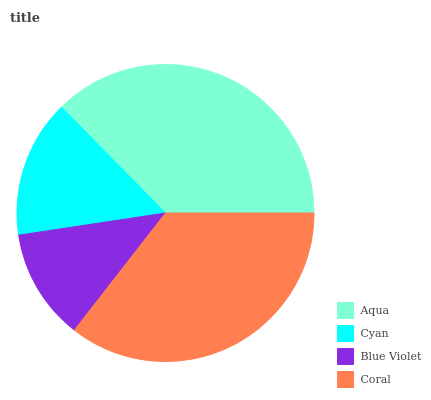Is Blue Violet the minimum?
Answer yes or no. Yes. Is Aqua the maximum?
Answer yes or no. Yes. Is Cyan the minimum?
Answer yes or no. No. Is Cyan the maximum?
Answer yes or no. No. Is Aqua greater than Cyan?
Answer yes or no. Yes. Is Cyan less than Aqua?
Answer yes or no. Yes. Is Cyan greater than Aqua?
Answer yes or no. No. Is Aqua less than Cyan?
Answer yes or no. No. Is Coral the high median?
Answer yes or no. Yes. Is Cyan the low median?
Answer yes or no. Yes. Is Blue Violet the high median?
Answer yes or no. No. Is Aqua the low median?
Answer yes or no. No. 